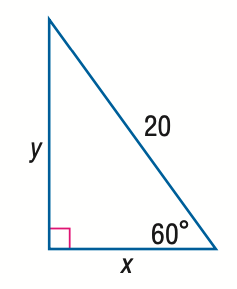Answer the mathemtical geometry problem and directly provide the correct option letter.
Question: Find x.
Choices: A: 10 B: 10 \sqrt { 2 } C: 10 \sqrt { 3 } D: 20 A 